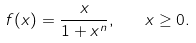Convert formula to latex. <formula><loc_0><loc_0><loc_500><loc_500>f ( x ) = \frac { x } { 1 + x ^ { n } } , \quad x \geq 0 .</formula> 